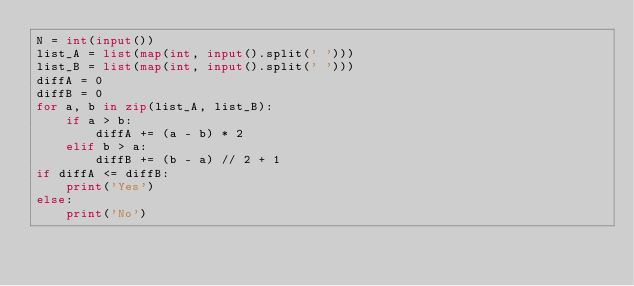Convert code to text. <code><loc_0><loc_0><loc_500><loc_500><_Python_>N = int(input())
list_A = list(map(int, input().split(' ')))
list_B = list(map(int, input().split(' ')))
diffA = 0
diffB = 0
for a, b in zip(list_A, list_B):
    if a > b:
        diffA += (a - b) * 2
    elif b > a:
        diffB += (b - a) // 2 + 1
if diffA <= diffB:
    print('Yes')
else:
    print('No')</code> 